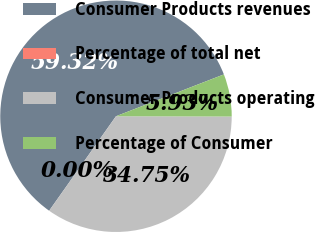<chart> <loc_0><loc_0><loc_500><loc_500><pie_chart><fcel>Consumer Products revenues<fcel>Percentage of total net<fcel>Consumer Products operating<fcel>Percentage of Consumer<nl><fcel>59.31%<fcel>0.0%<fcel>34.75%<fcel>5.93%<nl></chart> 